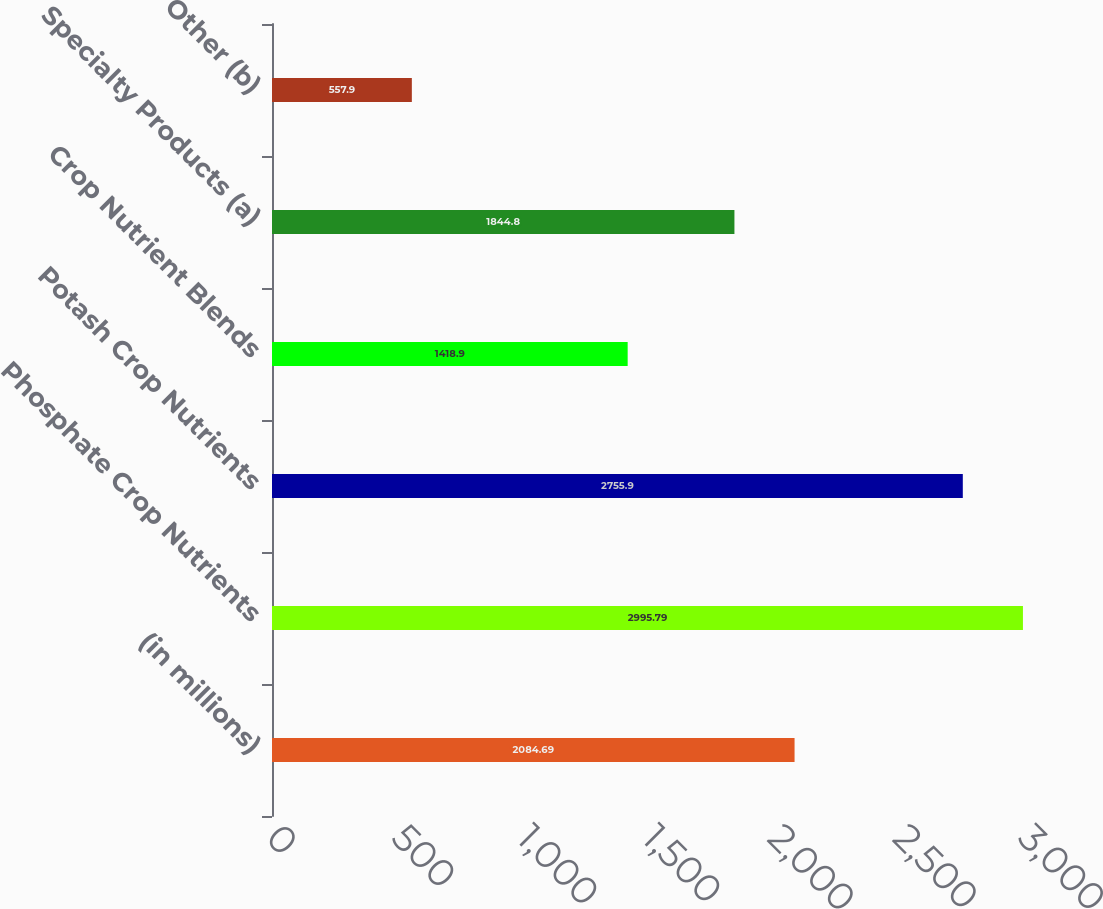<chart> <loc_0><loc_0><loc_500><loc_500><bar_chart><fcel>(in millions)<fcel>Phosphate Crop Nutrients<fcel>Potash Crop Nutrients<fcel>Crop Nutrient Blends<fcel>Specialty Products (a)<fcel>Other (b)<nl><fcel>2084.69<fcel>2995.79<fcel>2755.9<fcel>1418.9<fcel>1844.8<fcel>557.9<nl></chart> 